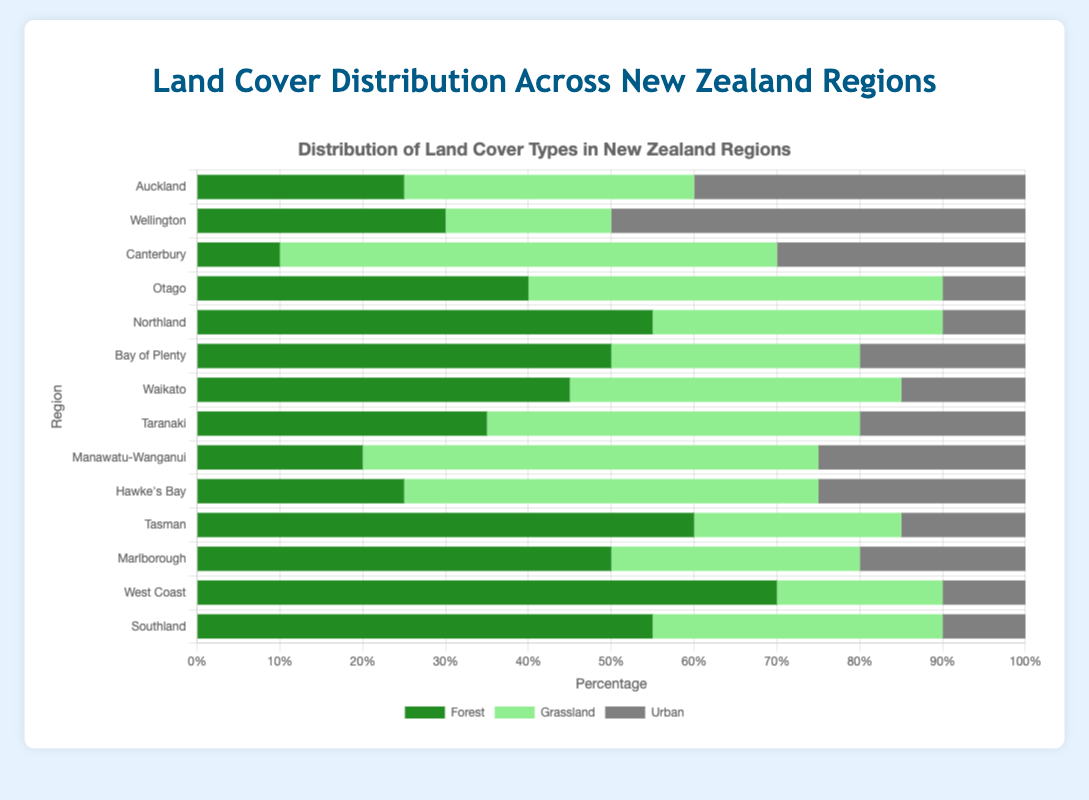Which region has the highest percentage of forest cover? Observing the length of the green bars, the West Coast bar is the longest. West Coast has 70% forest cover.
Answer: West Coast Which region has the lowest percentage of urban area? The shortest grey bar represents the region with the lowest percentage of urban area, which are Northland, West Coast, and Southland each with 10% urban cover.
Answer: Northland, West Coast, Southland Which region has a greater percentage of grasslands, Canterbury or Manawatu-Wanganui? Comparing the length of the light green bars for both regions, Canterbury's bar is longer. Canterbury has 60% grasslands, while Manawatu-Wanganui has 55%.
Answer: Canterbury What is the total percentage of forest and urban areas in Auckland? Sum the percentage of forest (25%) and urban (40%) areas in Auckland. 25 + 40 = 65%
Answer: 65% Between Tasman and Bay of Plenty, which region has a higher combined percentage of forest and grassland areas? Sum the percentages of forest and grassland for both regions. Tasman: 60 + 25 = 85%; Bay of Plenty: 50 + 30 = 80%, so Tasman has a higher combined percentage.
Answer: Tasman Among the regions Waikato, Marlborough, and Taranaki, which one has the highest urban area percentage? Comparing the grey bars for these regions, Marlborough has the longest grey bar at 20%.
Answer: Marlborough What is the average percentage of grassland in Taranaki, Northland, and Southland? Sum the grassland percentages and divide by the number of regions: (45 + 35 + 35)/3 = 115/3 ≈ 38.33%
Answer: 38.33% How much greater is the forest percentage in West Coast compared to Canterbury? Subtract the forest percentage of Canterbury from that of West Coast: 70 - 10 = 60%
Answer: 60% Which regions have exactly 50% of their area covered by grasslands? Look at the grassland bars; Otago and Hawke's Bay each have a 50%.
Answer: Otago, Hawke's Bay 